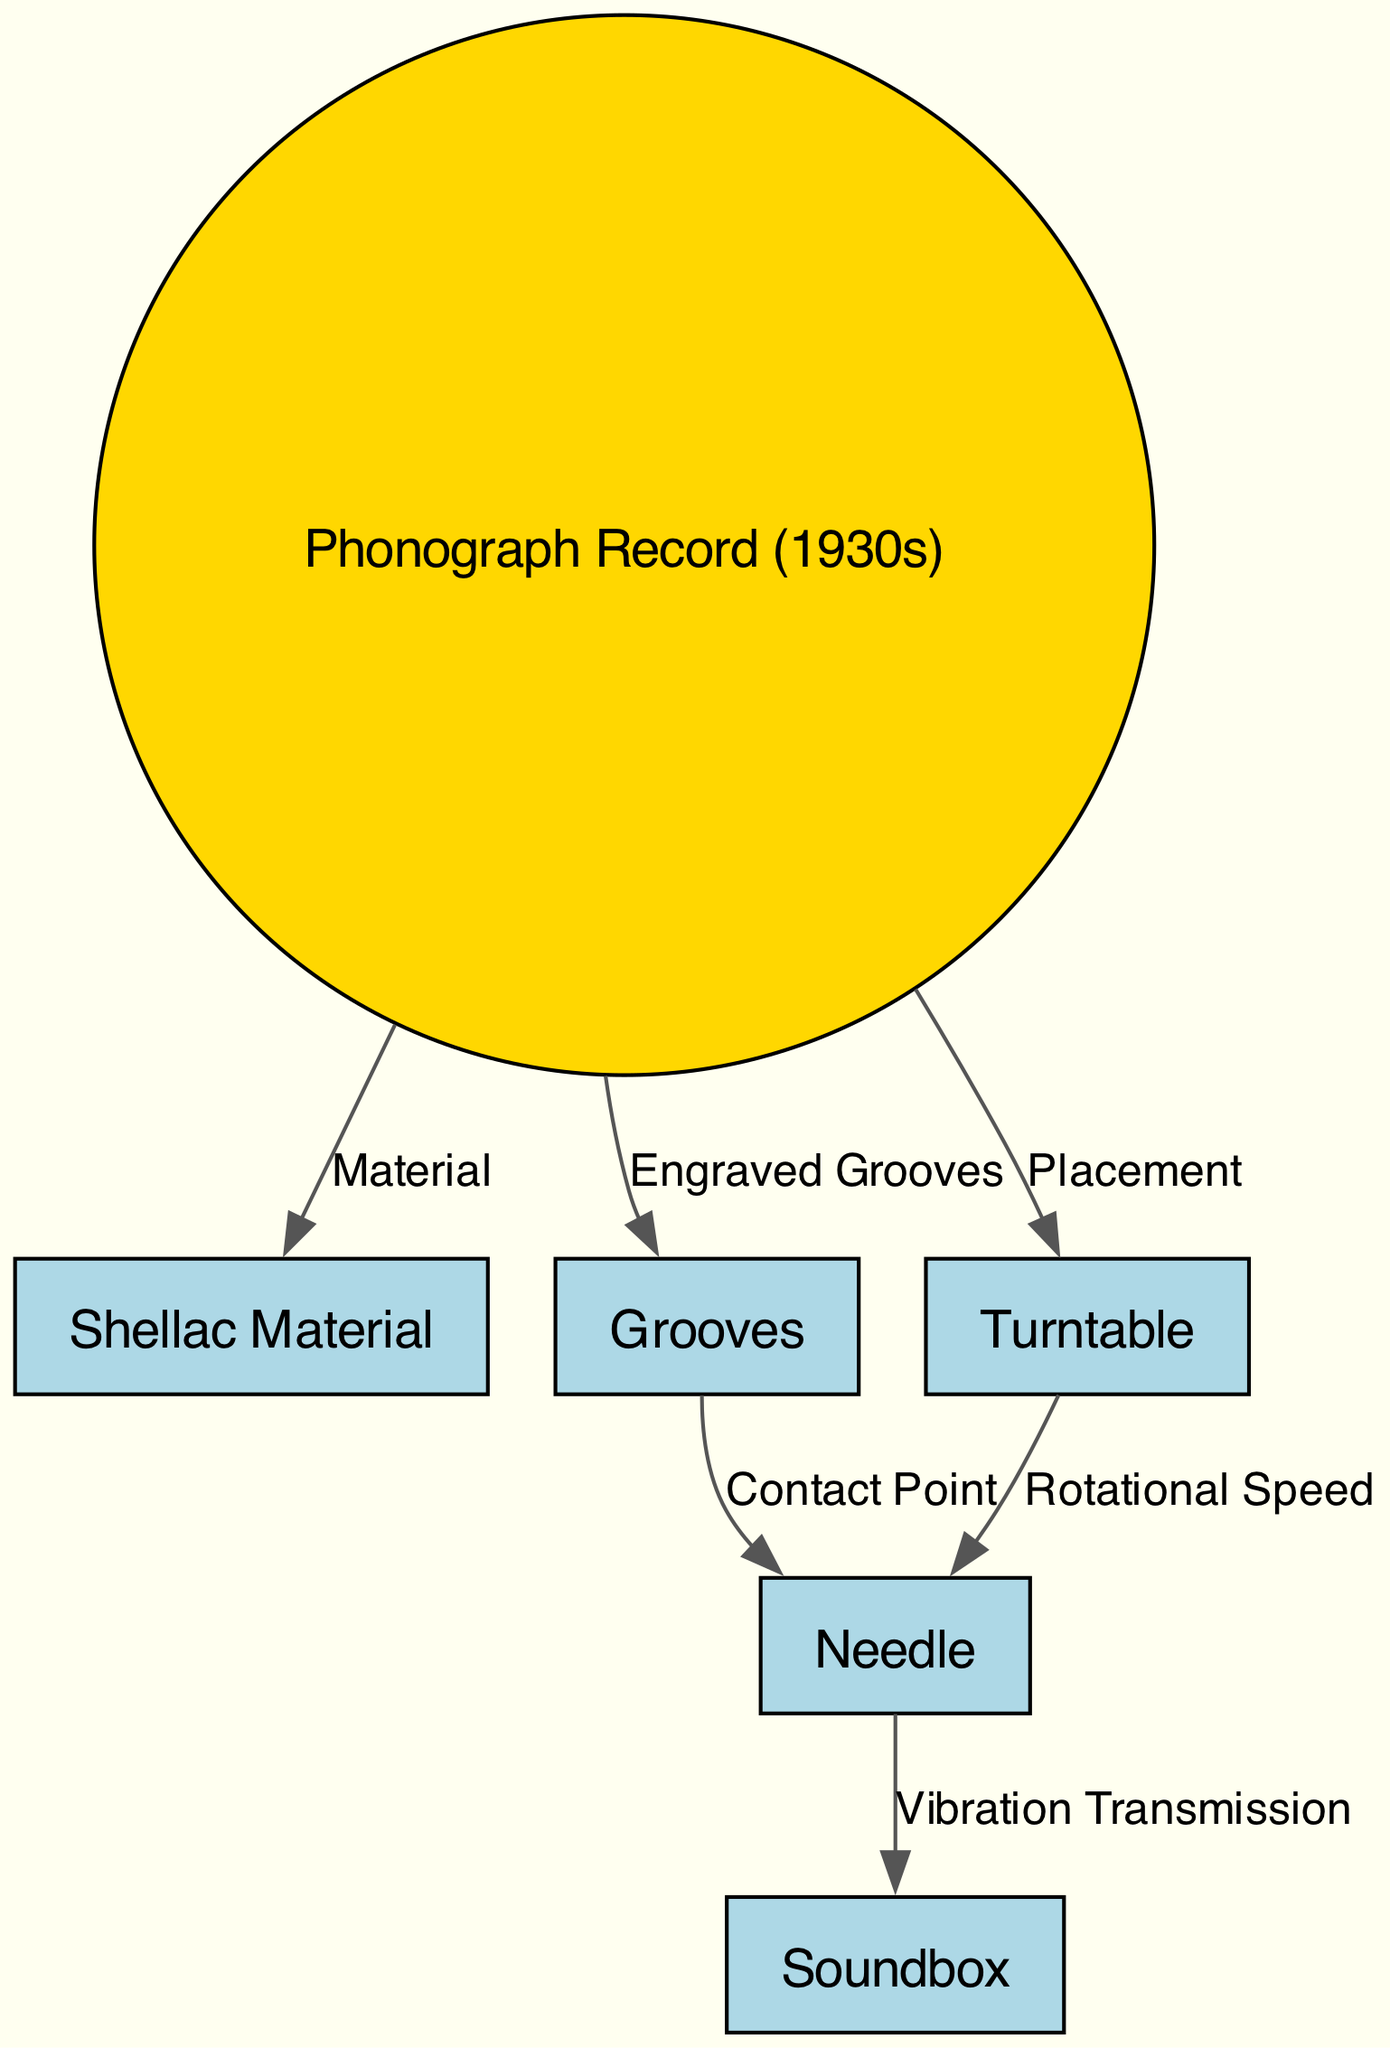What material is the phonograph record made of? The diagram indicates that the phonograph record is made from shellac, which is specifically labeled in the edge connecting the record to the shellac material node.
Answer: Shellac Material How many nodes are present in the diagram? By counting all the unique labeled elements visually represented in the diagram, we find there are six nodes: the phonograph record, shellac, grooves, needle, soundbox, and turntable.
Answer: 6 What is the role of grooves in the phonograph record? The grooves are labeled as engraved grooves in the diagram, which implies they play a crucial role in storing sound information and provide the contact point for the needle, allowing for sound reproduction.
Answer: Engraved Grooves What does the needle transmit vibrations to? The needle is shown in the diagram to transmit vibrations to the soundbox, as indicated by the edge labeled "Vibration Transmission." This detail highlights the function of the needle in the sound reproduction process.
Answer: Soundbox What connects the turntable to the needle? The diagram shows that the turntable connects to the needle through the edge labeled "Rotational Speed," which suggests that the turntable's speed affects the needle's performance during playback.
Answer: Rotational Speed How does the needle contact the grooves? The diagram indicates that the needle makes contact with the grooves, illuminating the relationship between these two elements labeled with the edge "Contact Point." This connection is essential for sound reproduction.
Answer: Contact Point Which component is placed on the turntable? The diagram states that the phonograph record is placed on the turntable, which is directly connected by an edge labeled "Placement." This relationship clarifies how the record is set up for playback.
Answer: Phonograph Record What is the purpose of the soundbox? The soundbox's purpose in the diagram is to amplify the sound transmitted from the needle, although it does not specify this function explicitly, its position indicates it plays a critical role in sound output.
Answer: Amplification of Sound 